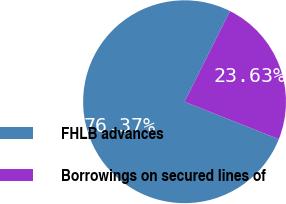<chart> <loc_0><loc_0><loc_500><loc_500><pie_chart><fcel>FHLB advances<fcel>Borrowings on secured lines of<nl><fcel>76.37%<fcel>23.63%<nl></chart> 